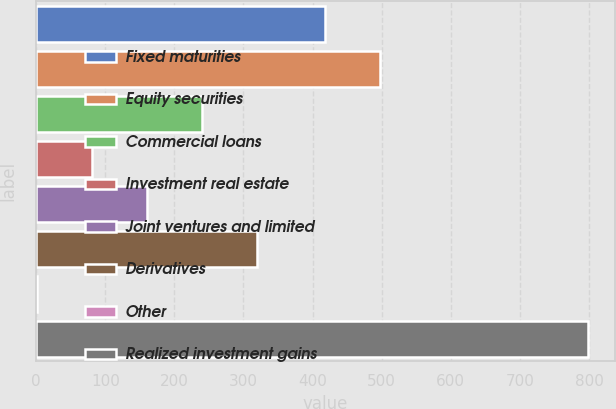Convert chart to OTSL. <chart><loc_0><loc_0><loc_500><loc_500><bar_chart><fcel>Fixed maturities<fcel>Equity securities<fcel>Commercial loans<fcel>Investment real estate<fcel>Joint ventures and limited<fcel>Derivatives<fcel>Other<fcel>Realized investment gains<nl><fcel>418<fcel>497.7<fcel>240.1<fcel>80.7<fcel>160.4<fcel>319.8<fcel>1<fcel>798<nl></chart> 